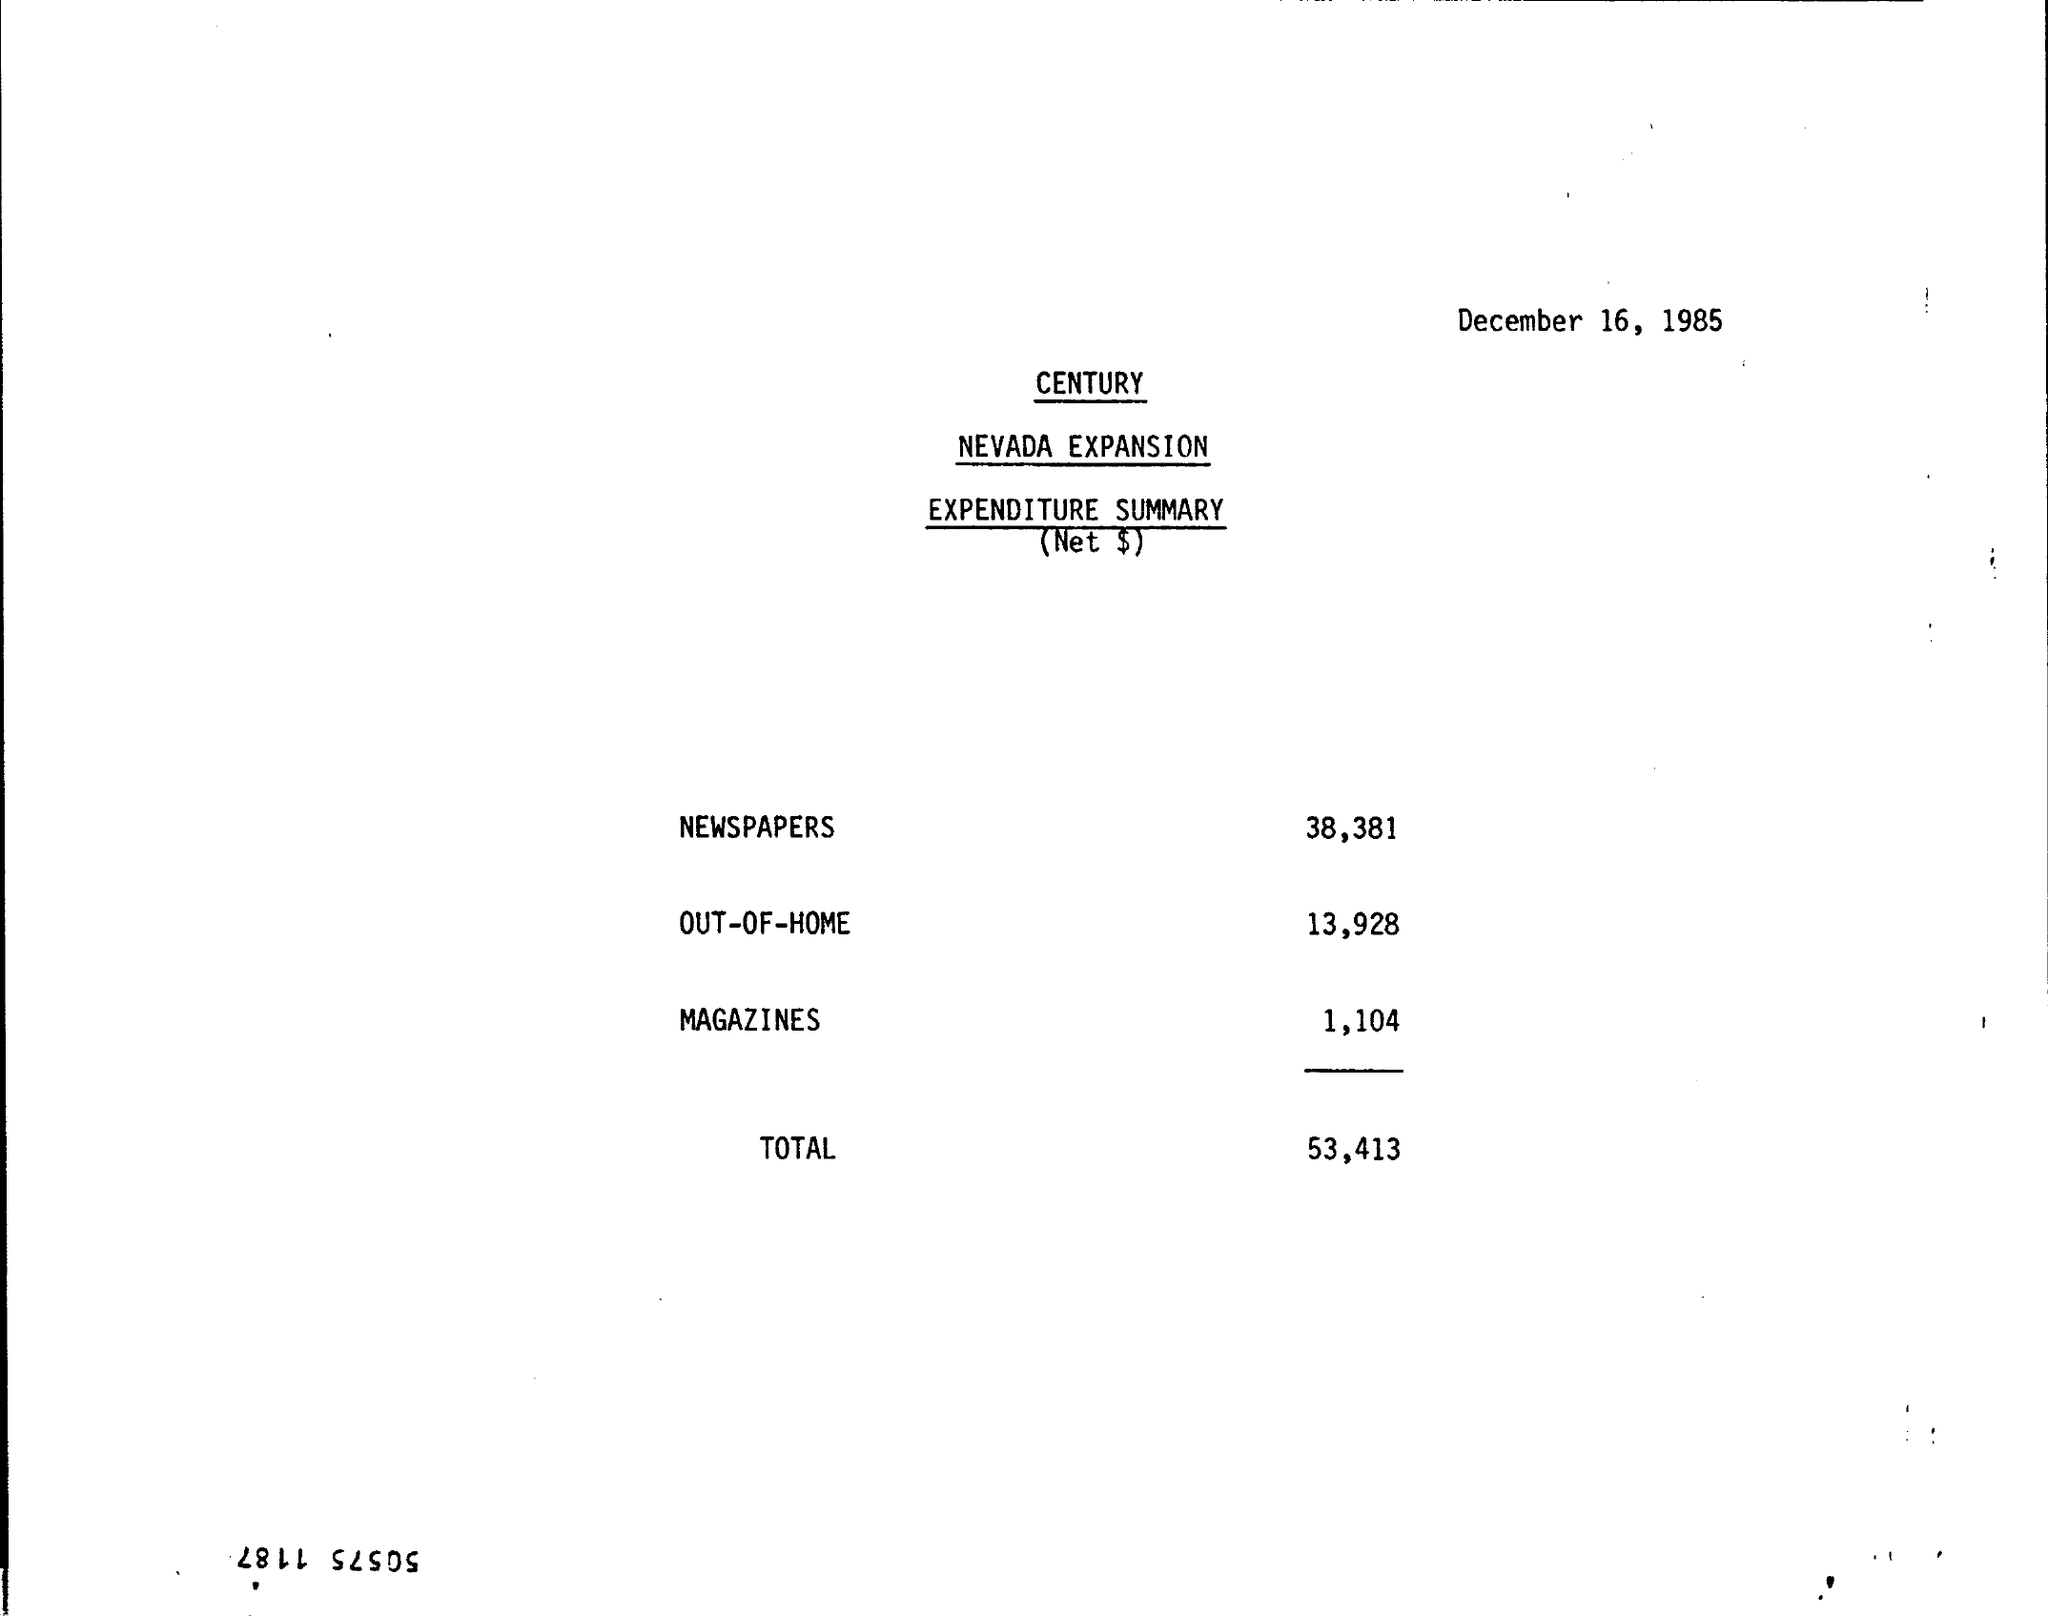Point out several critical features in this image. The expense for magazines is 1,104. The newspaper expense is 38,381. The total expense is 53,413. The expense for OUT-OF-HOME is 13,928. 